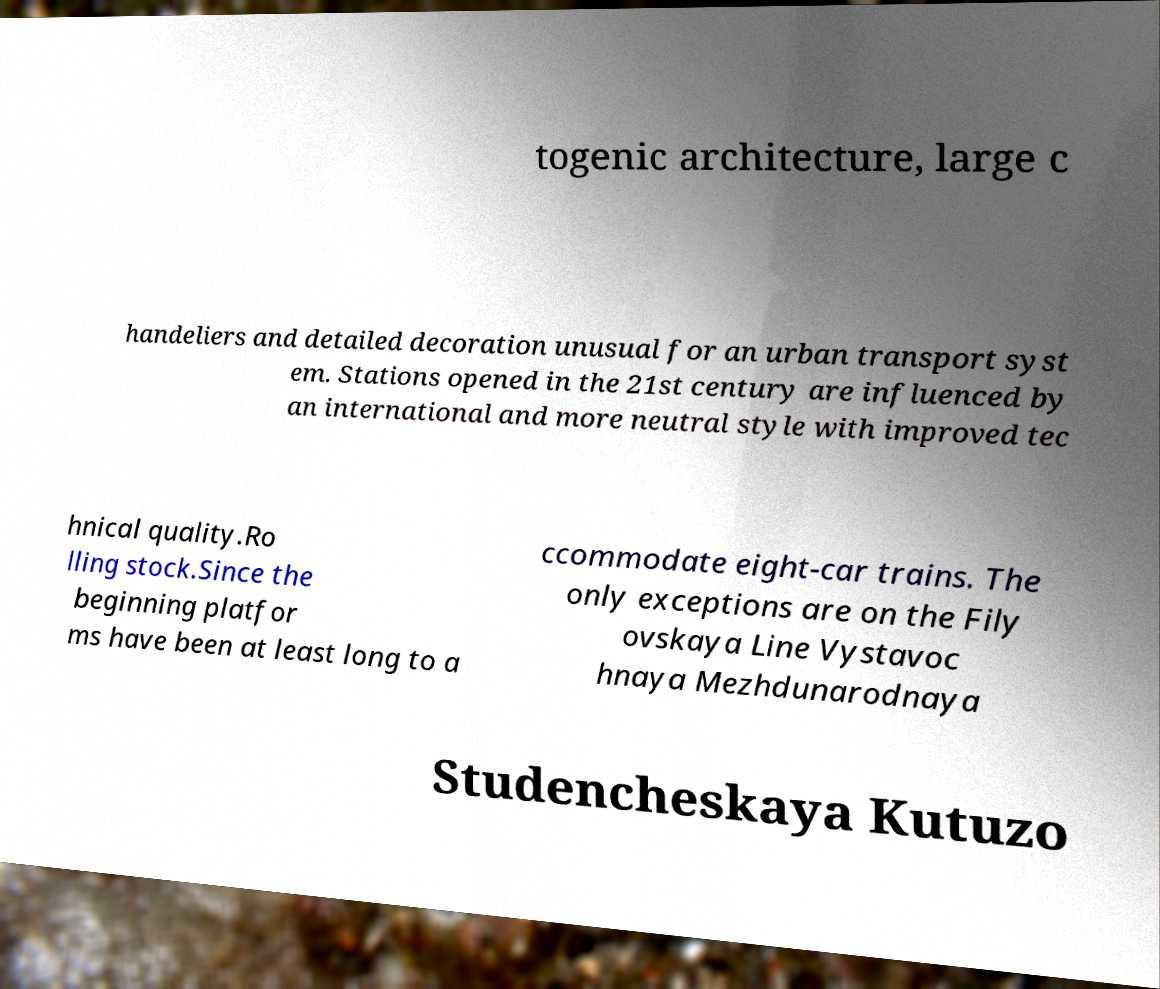Could you assist in decoding the text presented in this image and type it out clearly? togenic architecture, large c handeliers and detailed decoration unusual for an urban transport syst em. Stations opened in the 21st century are influenced by an international and more neutral style with improved tec hnical quality.Ro lling stock.Since the beginning platfor ms have been at least long to a ccommodate eight-car trains. The only exceptions are on the Fily ovskaya Line Vystavoc hnaya Mezhdunarodnaya Studencheskaya Kutuzo 